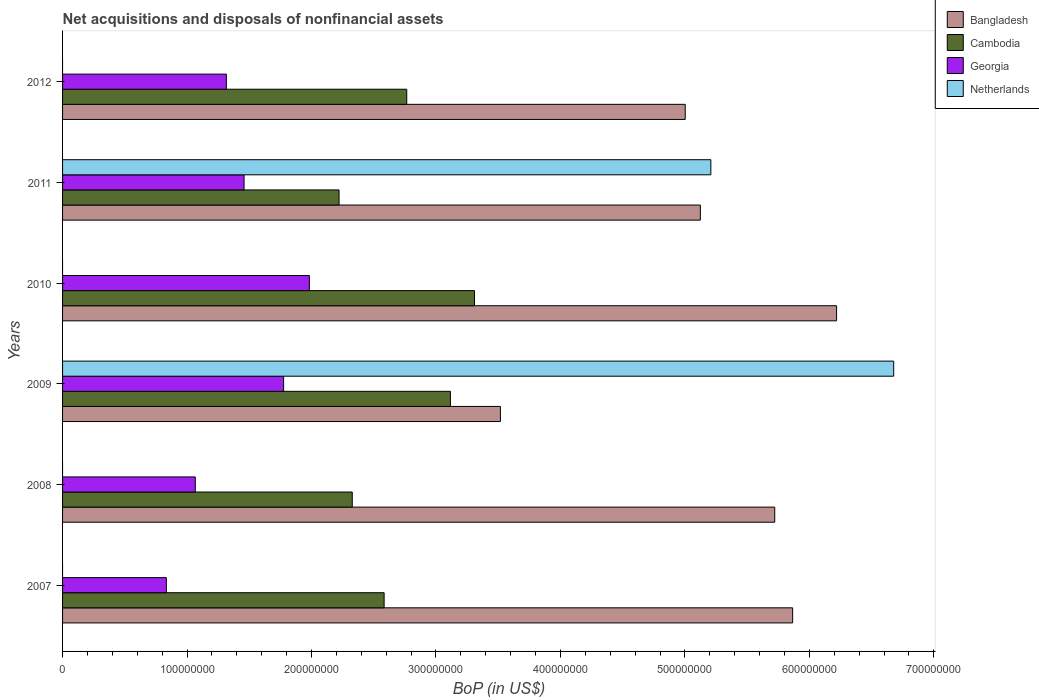Are the number of bars per tick equal to the number of legend labels?
Your response must be concise. No. What is the Balance of Payments in Cambodia in 2011?
Keep it short and to the point. 2.22e+08. Across all years, what is the maximum Balance of Payments in Netherlands?
Your answer should be compact. 6.68e+08. Across all years, what is the minimum Balance of Payments in Bangladesh?
Your answer should be compact. 3.52e+08. What is the total Balance of Payments in Cambodia in the graph?
Provide a short and direct response. 1.63e+09. What is the difference between the Balance of Payments in Bangladesh in 2007 and that in 2009?
Offer a very short reply. 2.35e+08. What is the difference between the Balance of Payments in Netherlands in 2009 and the Balance of Payments in Georgia in 2011?
Keep it short and to the point. 5.22e+08. What is the average Balance of Payments in Bangladesh per year?
Your response must be concise. 5.24e+08. In the year 2009, what is the difference between the Balance of Payments in Bangladesh and Balance of Payments in Georgia?
Provide a succinct answer. 1.74e+08. In how many years, is the Balance of Payments in Bangladesh greater than 60000000 US$?
Offer a very short reply. 6. What is the ratio of the Balance of Payments in Cambodia in 2008 to that in 2012?
Your answer should be compact. 0.84. Is the Balance of Payments in Bangladesh in 2008 less than that in 2011?
Make the answer very short. No. Is the difference between the Balance of Payments in Bangladesh in 2007 and 2009 greater than the difference between the Balance of Payments in Georgia in 2007 and 2009?
Keep it short and to the point. Yes. What is the difference between the highest and the second highest Balance of Payments in Bangladesh?
Offer a terse response. 3.53e+07. What is the difference between the highest and the lowest Balance of Payments in Cambodia?
Provide a short and direct response. 1.09e+08. Is it the case that in every year, the sum of the Balance of Payments in Georgia and Balance of Payments in Cambodia is greater than the sum of Balance of Payments in Bangladesh and Balance of Payments in Netherlands?
Provide a short and direct response. Yes. What is the difference between two consecutive major ticks on the X-axis?
Ensure brevity in your answer.  1.00e+08. Are the values on the major ticks of X-axis written in scientific E-notation?
Make the answer very short. No. Does the graph contain grids?
Offer a terse response. No. What is the title of the graph?
Give a very brief answer. Net acquisitions and disposals of nonfinancial assets. Does "Pakistan" appear as one of the legend labels in the graph?
Your answer should be compact. No. What is the label or title of the X-axis?
Provide a succinct answer. BoP (in US$). What is the label or title of the Y-axis?
Give a very brief answer. Years. What is the BoP (in US$) of Bangladesh in 2007?
Give a very brief answer. 5.87e+08. What is the BoP (in US$) in Cambodia in 2007?
Provide a short and direct response. 2.58e+08. What is the BoP (in US$) of Georgia in 2007?
Your answer should be very brief. 8.34e+07. What is the BoP (in US$) in Netherlands in 2007?
Your response must be concise. 0. What is the BoP (in US$) in Bangladesh in 2008?
Your answer should be very brief. 5.72e+08. What is the BoP (in US$) in Cambodia in 2008?
Offer a very short reply. 2.33e+08. What is the BoP (in US$) of Georgia in 2008?
Give a very brief answer. 1.07e+08. What is the BoP (in US$) of Netherlands in 2008?
Offer a terse response. 0. What is the BoP (in US$) in Bangladesh in 2009?
Your response must be concise. 3.52e+08. What is the BoP (in US$) in Cambodia in 2009?
Keep it short and to the point. 3.12e+08. What is the BoP (in US$) in Georgia in 2009?
Your response must be concise. 1.78e+08. What is the BoP (in US$) in Netherlands in 2009?
Provide a short and direct response. 6.68e+08. What is the BoP (in US$) of Bangladesh in 2010?
Your answer should be very brief. 6.22e+08. What is the BoP (in US$) of Cambodia in 2010?
Offer a very short reply. 3.31e+08. What is the BoP (in US$) of Georgia in 2010?
Your answer should be compact. 1.98e+08. What is the BoP (in US$) in Netherlands in 2010?
Your response must be concise. 0. What is the BoP (in US$) of Bangladesh in 2011?
Your answer should be compact. 5.12e+08. What is the BoP (in US$) in Cambodia in 2011?
Provide a succinct answer. 2.22e+08. What is the BoP (in US$) of Georgia in 2011?
Give a very brief answer. 1.46e+08. What is the BoP (in US$) of Netherlands in 2011?
Provide a succinct answer. 5.21e+08. What is the BoP (in US$) in Bangladesh in 2012?
Your response must be concise. 5.00e+08. What is the BoP (in US$) in Cambodia in 2012?
Make the answer very short. 2.77e+08. What is the BoP (in US$) in Georgia in 2012?
Ensure brevity in your answer.  1.32e+08. What is the BoP (in US$) of Netherlands in 2012?
Offer a terse response. 0. Across all years, what is the maximum BoP (in US$) of Bangladesh?
Your answer should be compact. 6.22e+08. Across all years, what is the maximum BoP (in US$) in Cambodia?
Give a very brief answer. 3.31e+08. Across all years, what is the maximum BoP (in US$) in Georgia?
Ensure brevity in your answer.  1.98e+08. Across all years, what is the maximum BoP (in US$) of Netherlands?
Offer a terse response. 6.68e+08. Across all years, what is the minimum BoP (in US$) in Bangladesh?
Provide a succinct answer. 3.52e+08. Across all years, what is the minimum BoP (in US$) in Cambodia?
Your response must be concise. 2.22e+08. Across all years, what is the minimum BoP (in US$) in Georgia?
Give a very brief answer. 8.34e+07. What is the total BoP (in US$) in Bangladesh in the graph?
Your answer should be very brief. 3.15e+09. What is the total BoP (in US$) in Cambodia in the graph?
Your answer should be compact. 1.63e+09. What is the total BoP (in US$) of Georgia in the graph?
Your answer should be compact. 8.43e+08. What is the total BoP (in US$) in Netherlands in the graph?
Make the answer very short. 1.19e+09. What is the difference between the BoP (in US$) in Bangladesh in 2007 and that in 2008?
Ensure brevity in your answer.  1.44e+07. What is the difference between the BoP (in US$) of Cambodia in 2007 and that in 2008?
Your answer should be compact. 2.56e+07. What is the difference between the BoP (in US$) in Georgia in 2007 and that in 2008?
Your answer should be compact. -2.32e+07. What is the difference between the BoP (in US$) in Bangladesh in 2007 and that in 2009?
Ensure brevity in your answer.  2.35e+08. What is the difference between the BoP (in US$) in Cambodia in 2007 and that in 2009?
Provide a short and direct response. -5.33e+07. What is the difference between the BoP (in US$) of Georgia in 2007 and that in 2009?
Make the answer very short. -9.42e+07. What is the difference between the BoP (in US$) in Bangladesh in 2007 and that in 2010?
Give a very brief answer. -3.53e+07. What is the difference between the BoP (in US$) of Cambodia in 2007 and that in 2010?
Offer a very short reply. -7.26e+07. What is the difference between the BoP (in US$) in Georgia in 2007 and that in 2010?
Provide a short and direct response. -1.15e+08. What is the difference between the BoP (in US$) of Bangladesh in 2007 and that in 2011?
Make the answer very short. 7.41e+07. What is the difference between the BoP (in US$) in Cambodia in 2007 and that in 2011?
Ensure brevity in your answer.  3.62e+07. What is the difference between the BoP (in US$) of Georgia in 2007 and that in 2011?
Ensure brevity in your answer.  -6.24e+07. What is the difference between the BoP (in US$) of Bangladesh in 2007 and that in 2012?
Provide a short and direct response. 8.63e+07. What is the difference between the BoP (in US$) in Cambodia in 2007 and that in 2012?
Ensure brevity in your answer.  -1.82e+07. What is the difference between the BoP (in US$) of Georgia in 2007 and that in 2012?
Make the answer very short. -4.82e+07. What is the difference between the BoP (in US$) of Bangladesh in 2008 and that in 2009?
Give a very brief answer. 2.20e+08. What is the difference between the BoP (in US$) of Cambodia in 2008 and that in 2009?
Provide a short and direct response. -7.89e+07. What is the difference between the BoP (in US$) in Georgia in 2008 and that in 2009?
Your response must be concise. -7.10e+07. What is the difference between the BoP (in US$) in Bangladesh in 2008 and that in 2010?
Your answer should be compact. -4.97e+07. What is the difference between the BoP (in US$) of Cambodia in 2008 and that in 2010?
Offer a terse response. -9.82e+07. What is the difference between the BoP (in US$) in Georgia in 2008 and that in 2010?
Ensure brevity in your answer.  -9.17e+07. What is the difference between the BoP (in US$) of Bangladesh in 2008 and that in 2011?
Your answer should be compact. 5.98e+07. What is the difference between the BoP (in US$) in Cambodia in 2008 and that in 2011?
Your answer should be very brief. 1.06e+07. What is the difference between the BoP (in US$) of Georgia in 2008 and that in 2011?
Provide a succinct answer. -3.92e+07. What is the difference between the BoP (in US$) in Bangladesh in 2008 and that in 2012?
Keep it short and to the point. 7.19e+07. What is the difference between the BoP (in US$) of Cambodia in 2008 and that in 2012?
Make the answer very short. -4.38e+07. What is the difference between the BoP (in US$) in Georgia in 2008 and that in 2012?
Your response must be concise. -2.50e+07. What is the difference between the BoP (in US$) of Bangladesh in 2009 and that in 2010?
Your response must be concise. -2.70e+08. What is the difference between the BoP (in US$) in Cambodia in 2009 and that in 2010?
Your answer should be very brief. -1.94e+07. What is the difference between the BoP (in US$) of Georgia in 2009 and that in 2010?
Your answer should be very brief. -2.07e+07. What is the difference between the BoP (in US$) in Bangladesh in 2009 and that in 2011?
Offer a terse response. -1.61e+08. What is the difference between the BoP (in US$) in Cambodia in 2009 and that in 2011?
Your response must be concise. 8.95e+07. What is the difference between the BoP (in US$) of Georgia in 2009 and that in 2011?
Ensure brevity in your answer.  3.18e+07. What is the difference between the BoP (in US$) in Netherlands in 2009 and that in 2011?
Give a very brief answer. 1.47e+08. What is the difference between the BoP (in US$) of Bangladesh in 2009 and that in 2012?
Your response must be concise. -1.48e+08. What is the difference between the BoP (in US$) of Cambodia in 2009 and that in 2012?
Your response must be concise. 3.51e+07. What is the difference between the BoP (in US$) in Georgia in 2009 and that in 2012?
Provide a succinct answer. 4.60e+07. What is the difference between the BoP (in US$) of Bangladesh in 2010 and that in 2011?
Your answer should be compact. 1.09e+08. What is the difference between the BoP (in US$) of Cambodia in 2010 and that in 2011?
Make the answer very short. 1.09e+08. What is the difference between the BoP (in US$) in Georgia in 2010 and that in 2011?
Ensure brevity in your answer.  5.25e+07. What is the difference between the BoP (in US$) of Bangladesh in 2010 and that in 2012?
Your response must be concise. 1.22e+08. What is the difference between the BoP (in US$) of Cambodia in 2010 and that in 2012?
Offer a terse response. 5.44e+07. What is the difference between the BoP (in US$) in Georgia in 2010 and that in 2012?
Ensure brevity in your answer.  6.67e+07. What is the difference between the BoP (in US$) of Bangladesh in 2011 and that in 2012?
Keep it short and to the point. 1.21e+07. What is the difference between the BoP (in US$) in Cambodia in 2011 and that in 2012?
Give a very brief answer. -5.44e+07. What is the difference between the BoP (in US$) in Georgia in 2011 and that in 2012?
Your answer should be compact. 1.42e+07. What is the difference between the BoP (in US$) in Bangladesh in 2007 and the BoP (in US$) in Cambodia in 2008?
Ensure brevity in your answer.  3.54e+08. What is the difference between the BoP (in US$) of Bangladesh in 2007 and the BoP (in US$) of Georgia in 2008?
Your answer should be compact. 4.80e+08. What is the difference between the BoP (in US$) of Cambodia in 2007 and the BoP (in US$) of Georgia in 2008?
Provide a short and direct response. 1.52e+08. What is the difference between the BoP (in US$) of Bangladesh in 2007 and the BoP (in US$) of Cambodia in 2009?
Make the answer very short. 2.75e+08. What is the difference between the BoP (in US$) of Bangladesh in 2007 and the BoP (in US$) of Georgia in 2009?
Ensure brevity in your answer.  4.09e+08. What is the difference between the BoP (in US$) in Bangladesh in 2007 and the BoP (in US$) in Netherlands in 2009?
Offer a very short reply. -8.12e+07. What is the difference between the BoP (in US$) of Cambodia in 2007 and the BoP (in US$) of Georgia in 2009?
Provide a succinct answer. 8.07e+07. What is the difference between the BoP (in US$) in Cambodia in 2007 and the BoP (in US$) in Netherlands in 2009?
Your answer should be compact. -4.09e+08. What is the difference between the BoP (in US$) of Georgia in 2007 and the BoP (in US$) of Netherlands in 2009?
Give a very brief answer. -5.84e+08. What is the difference between the BoP (in US$) of Bangladesh in 2007 and the BoP (in US$) of Cambodia in 2010?
Ensure brevity in your answer.  2.56e+08. What is the difference between the BoP (in US$) of Bangladesh in 2007 and the BoP (in US$) of Georgia in 2010?
Make the answer very short. 3.88e+08. What is the difference between the BoP (in US$) of Cambodia in 2007 and the BoP (in US$) of Georgia in 2010?
Provide a succinct answer. 6.01e+07. What is the difference between the BoP (in US$) of Bangladesh in 2007 and the BoP (in US$) of Cambodia in 2011?
Your answer should be very brief. 3.64e+08. What is the difference between the BoP (in US$) in Bangladesh in 2007 and the BoP (in US$) in Georgia in 2011?
Provide a short and direct response. 4.41e+08. What is the difference between the BoP (in US$) of Bangladesh in 2007 and the BoP (in US$) of Netherlands in 2011?
Provide a succinct answer. 6.57e+07. What is the difference between the BoP (in US$) of Cambodia in 2007 and the BoP (in US$) of Georgia in 2011?
Your answer should be very brief. 1.13e+08. What is the difference between the BoP (in US$) in Cambodia in 2007 and the BoP (in US$) in Netherlands in 2011?
Make the answer very short. -2.62e+08. What is the difference between the BoP (in US$) of Georgia in 2007 and the BoP (in US$) of Netherlands in 2011?
Keep it short and to the point. -4.37e+08. What is the difference between the BoP (in US$) of Bangladesh in 2007 and the BoP (in US$) of Cambodia in 2012?
Give a very brief answer. 3.10e+08. What is the difference between the BoP (in US$) in Bangladesh in 2007 and the BoP (in US$) in Georgia in 2012?
Give a very brief answer. 4.55e+08. What is the difference between the BoP (in US$) in Cambodia in 2007 and the BoP (in US$) in Georgia in 2012?
Ensure brevity in your answer.  1.27e+08. What is the difference between the BoP (in US$) in Bangladesh in 2008 and the BoP (in US$) in Cambodia in 2009?
Your answer should be very brief. 2.61e+08. What is the difference between the BoP (in US$) of Bangladesh in 2008 and the BoP (in US$) of Georgia in 2009?
Your answer should be compact. 3.95e+08. What is the difference between the BoP (in US$) of Bangladesh in 2008 and the BoP (in US$) of Netherlands in 2009?
Your answer should be compact. -9.56e+07. What is the difference between the BoP (in US$) of Cambodia in 2008 and the BoP (in US$) of Georgia in 2009?
Offer a very short reply. 5.51e+07. What is the difference between the BoP (in US$) in Cambodia in 2008 and the BoP (in US$) in Netherlands in 2009?
Your answer should be compact. -4.35e+08. What is the difference between the BoP (in US$) in Georgia in 2008 and the BoP (in US$) in Netherlands in 2009?
Offer a very short reply. -5.61e+08. What is the difference between the BoP (in US$) in Bangladesh in 2008 and the BoP (in US$) in Cambodia in 2010?
Offer a terse response. 2.41e+08. What is the difference between the BoP (in US$) of Bangladesh in 2008 and the BoP (in US$) of Georgia in 2010?
Offer a terse response. 3.74e+08. What is the difference between the BoP (in US$) in Cambodia in 2008 and the BoP (in US$) in Georgia in 2010?
Your answer should be very brief. 3.45e+07. What is the difference between the BoP (in US$) in Bangladesh in 2008 and the BoP (in US$) in Cambodia in 2011?
Your answer should be compact. 3.50e+08. What is the difference between the BoP (in US$) of Bangladesh in 2008 and the BoP (in US$) of Georgia in 2011?
Offer a terse response. 4.26e+08. What is the difference between the BoP (in US$) in Bangladesh in 2008 and the BoP (in US$) in Netherlands in 2011?
Ensure brevity in your answer.  5.13e+07. What is the difference between the BoP (in US$) in Cambodia in 2008 and the BoP (in US$) in Georgia in 2011?
Provide a succinct answer. 8.69e+07. What is the difference between the BoP (in US$) of Cambodia in 2008 and the BoP (in US$) of Netherlands in 2011?
Make the answer very short. -2.88e+08. What is the difference between the BoP (in US$) of Georgia in 2008 and the BoP (in US$) of Netherlands in 2011?
Keep it short and to the point. -4.14e+08. What is the difference between the BoP (in US$) in Bangladesh in 2008 and the BoP (in US$) in Cambodia in 2012?
Offer a very short reply. 2.96e+08. What is the difference between the BoP (in US$) in Bangladesh in 2008 and the BoP (in US$) in Georgia in 2012?
Keep it short and to the point. 4.41e+08. What is the difference between the BoP (in US$) in Cambodia in 2008 and the BoP (in US$) in Georgia in 2012?
Offer a terse response. 1.01e+08. What is the difference between the BoP (in US$) in Bangladesh in 2009 and the BoP (in US$) in Cambodia in 2010?
Make the answer very short. 2.08e+07. What is the difference between the BoP (in US$) in Bangladesh in 2009 and the BoP (in US$) in Georgia in 2010?
Offer a very short reply. 1.53e+08. What is the difference between the BoP (in US$) of Cambodia in 2009 and the BoP (in US$) of Georgia in 2010?
Provide a short and direct response. 1.13e+08. What is the difference between the BoP (in US$) of Bangladesh in 2009 and the BoP (in US$) of Cambodia in 2011?
Keep it short and to the point. 1.30e+08. What is the difference between the BoP (in US$) in Bangladesh in 2009 and the BoP (in US$) in Georgia in 2011?
Keep it short and to the point. 2.06e+08. What is the difference between the BoP (in US$) in Bangladesh in 2009 and the BoP (in US$) in Netherlands in 2011?
Your response must be concise. -1.69e+08. What is the difference between the BoP (in US$) of Cambodia in 2009 and the BoP (in US$) of Georgia in 2011?
Your answer should be compact. 1.66e+08. What is the difference between the BoP (in US$) of Cambodia in 2009 and the BoP (in US$) of Netherlands in 2011?
Offer a terse response. -2.09e+08. What is the difference between the BoP (in US$) in Georgia in 2009 and the BoP (in US$) in Netherlands in 2011?
Offer a terse response. -3.43e+08. What is the difference between the BoP (in US$) of Bangladesh in 2009 and the BoP (in US$) of Cambodia in 2012?
Make the answer very short. 7.52e+07. What is the difference between the BoP (in US$) in Bangladesh in 2009 and the BoP (in US$) in Georgia in 2012?
Keep it short and to the point. 2.20e+08. What is the difference between the BoP (in US$) in Cambodia in 2009 and the BoP (in US$) in Georgia in 2012?
Your response must be concise. 1.80e+08. What is the difference between the BoP (in US$) in Bangladesh in 2010 and the BoP (in US$) in Cambodia in 2011?
Keep it short and to the point. 4.00e+08. What is the difference between the BoP (in US$) in Bangladesh in 2010 and the BoP (in US$) in Georgia in 2011?
Your response must be concise. 4.76e+08. What is the difference between the BoP (in US$) in Bangladesh in 2010 and the BoP (in US$) in Netherlands in 2011?
Offer a very short reply. 1.01e+08. What is the difference between the BoP (in US$) of Cambodia in 2010 and the BoP (in US$) of Georgia in 2011?
Your answer should be very brief. 1.85e+08. What is the difference between the BoP (in US$) in Cambodia in 2010 and the BoP (in US$) in Netherlands in 2011?
Make the answer very short. -1.90e+08. What is the difference between the BoP (in US$) in Georgia in 2010 and the BoP (in US$) in Netherlands in 2011?
Provide a succinct answer. -3.23e+08. What is the difference between the BoP (in US$) of Bangladesh in 2010 and the BoP (in US$) of Cambodia in 2012?
Your answer should be very brief. 3.45e+08. What is the difference between the BoP (in US$) in Bangladesh in 2010 and the BoP (in US$) in Georgia in 2012?
Keep it short and to the point. 4.90e+08. What is the difference between the BoP (in US$) in Cambodia in 2010 and the BoP (in US$) in Georgia in 2012?
Your answer should be very brief. 1.99e+08. What is the difference between the BoP (in US$) of Bangladesh in 2011 and the BoP (in US$) of Cambodia in 2012?
Provide a succinct answer. 2.36e+08. What is the difference between the BoP (in US$) of Bangladesh in 2011 and the BoP (in US$) of Georgia in 2012?
Offer a very short reply. 3.81e+08. What is the difference between the BoP (in US$) in Cambodia in 2011 and the BoP (in US$) in Georgia in 2012?
Give a very brief answer. 9.05e+07. What is the average BoP (in US$) in Bangladesh per year?
Provide a succinct answer. 5.24e+08. What is the average BoP (in US$) of Cambodia per year?
Provide a succinct answer. 2.72e+08. What is the average BoP (in US$) of Georgia per year?
Offer a very short reply. 1.41e+08. What is the average BoP (in US$) in Netherlands per year?
Your answer should be very brief. 1.98e+08. In the year 2007, what is the difference between the BoP (in US$) in Bangladesh and BoP (in US$) in Cambodia?
Provide a succinct answer. 3.28e+08. In the year 2007, what is the difference between the BoP (in US$) of Bangladesh and BoP (in US$) of Georgia?
Ensure brevity in your answer.  5.03e+08. In the year 2007, what is the difference between the BoP (in US$) of Cambodia and BoP (in US$) of Georgia?
Provide a succinct answer. 1.75e+08. In the year 2008, what is the difference between the BoP (in US$) of Bangladesh and BoP (in US$) of Cambodia?
Offer a very short reply. 3.39e+08. In the year 2008, what is the difference between the BoP (in US$) in Bangladesh and BoP (in US$) in Georgia?
Offer a very short reply. 4.66e+08. In the year 2008, what is the difference between the BoP (in US$) in Cambodia and BoP (in US$) in Georgia?
Offer a very short reply. 1.26e+08. In the year 2009, what is the difference between the BoP (in US$) in Bangladesh and BoP (in US$) in Cambodia?
Offer a terse response. 4.02e+07. In the year 2009, what is the difference between the BoP (in US$) of Bangladesh and BoP (in US$) of Georgia?
Provide a short and direct response. 1.74e+08. In the year 2009, what is the difference between the BoP (in US$) in Bangladesh and BoP (in US$) in Netherlands?
Offer a very short reply. -3.16e+08. In the year 2009, what is the difference between the BoP (in US$) in Cambodia and BoP (in US$) in Georgia?
Offer a terse response. 1.34e+08. In the year 2009, what is the difference between the BoP (in US$) of Cambodia and BoP (in US$) of Netherlands?
Your answer should be very brief. -3.56e+08. In the year 2009, what is the difference between the BoP (in US$) in Georgia and BoP (in US$) in Netherlands?
Make the answer very short. -4.90e+08. In the year 2010, what is the difference between the BoP (in US$) in Bangladesh and BoP (in US$) in Cambodia?
Your response must be concise. 2.91e+08. In the year 2010, what is the difference between the BoP (in US$) in Bangladesh and BoP (in US$) in Georgia?
Your response must be concise. 4.24e+08. In the year 2010, what is the difference between the BoP (in US$) in Cambodia and BoP (in US$) in Georgia?
Offer a very short reply. 1.33e+08. In the year 2011, what is the difference between the BoP (in US$) in Bangladesh and BoP (in US$) in Cambodia?
Provide a succinct answer. 2.90e+08. In the year 2011, what is the difference between the BoP (in US$) in Bangladesh and BoP (in US$) in Georgia?
Provide a short and direct response. 3.67e+08. In the year 2011, what is the difference between the BoP (in US$) of Bangladesh and BoP (in US$) of Netherlands?
Your response must be concise. -8.43e+06. In the year 2011, what is the difference between the BoP (in US$) of Cambodia and BoP (in US$) of Georgia?
Your answer should be compact. 7.63e+07. In the year 2011, what is the difference between the BoP (in US$) in Cambodia and BoP (in US$) in Netherlands?
Make the answer very short. -2.99e+08. In the year 2011, what is the difference between the BoP (in US$) of Georgia and BoP (in US$) of Netherlands?
Make the answer very short. -3.75e+08. In the year 2012, what is the difference between the BoP (in US$) of Bangladesh and BoP (in US$) of Cambodia?
Ensure brevity in your answer.  2.24e+08. In the year 2012, what is the difference between the BoP (in US$) in Bangladesh and BoP (in US$) in Georgia?
Offer a terse response. 3.69e+08. In the year 2012, what is the difference between the BoP (in US$) in Cambodia and BoP (in US$) in Georgia?
Provide a short and direct response. 1.45e+08. What is the ratio of the BoP (in US$) in Bangladesh in 2007 to that in 2008?
Keep it short and to the point. 1.03. What is the ratio of the BoP (in US$) of Cambodia in 2007 to that in 2008?
Offer a terse response. 1.11. What is the ratio of the BoP (in US$) of Georgia in 2007 to that in 2008?
Your answer should be very brief. 0.78. What is the ratio of the BoP (in US$) of Bangladesh in 2007 to that in 2009?
Keep it short and to the point. 1.67. What is the ratio of the BoP (in US$) of Cambodia in 2007 to that in 2009?
Offer a very short reply. 0.83. What is the ratio of the BoP (in US$) in Georgia in 2007 to that in 2009?
Ensure brevity in your answer.  0.47. What is the ratio of the BoP (in US$) in Bangladesh in 2007 to that in 2010?
Offer a very short reply. 0.94. What is the ratio of the BoP (in US$) in Cambodia in 2007 to that in 2010?
Give a very brief answer. 0.78. What is the ratio of the BoP (in US$) of Georgia in 2007 to that in 2010?
Make the answer very short. 0.42. What is the ratio of the BoP (in US$) in Bangladesh in 2007 to that in 2011?
Offer a very short reply. 1.14. What is the ratio of the BoP (in US$) of Cambodia in 2007 to that in 2011?
Offer a very short reply. 1.16. What is the ratio of the BoP (in US$) in Georgia in 2007 to that in 2011?
Keep it short and to the point. 0.57. What is the ratio of the BoP (in US$) of Bangladesh in 2007 to that in 2012?
Give a very brief answer. 1.17. What is the ratio of the BoP (in US$) of Cambodia in 2007 to that in 2012?
Your answer should be compact. 0.93. What is the ratio of the BoP (in US$) in Georgia in 2007 to that in 2012?
Your answer should be compact. 0.63. What is the ratio of the BoP (in US$) in Bangladesh in 2008 to that in 2009?
Offer a very short reply. 1.63. What is the ratio of the BoP (in US$) of Cambodia in 2008 to that in 2009?
Provide a succinct answer. 0.75. What is the ratio of the BoP (in US$) in Georgia in 2008 to that in 2009?
Keep it short and to the point. 0.6. What is the ratio of the BoP (in US$) of Bangladesh in 2008 to that in 2010?
Ensure brevity in your answer.  0.92. What is the ratio of the BoP (in US$) in Cambodia in 2008 to that in 2010?
Offer a terse response. 0.7. What is the ratio of the BoP (in US$) in Georgia in 2008 to that in 2010?
Give a very brief answer. 0.54. What is the ratio of the BoP (in US$) in Bangladesh in 2008 to that in 2011?
Your answer should be very brief. 1.12. What is the ratio of the BoP (in US$) in Cambodia in 2008 to that in 2011?
Keep it short and to the point. 1.05. What is the ratio of the BoP (in US$) in Georgia in 2008 to that in 2011?
Make the answer very short. 0.73. What is the ratio of the BoP (in US$) in Bangladesh in 2008 to that in 2012?
Your answer should be compact. 1.14. What is the ratio of the BoP (in US$) in Cambodia in 2008 to that in 2012?
Give a very brief answer. 0.84. What is the ratio of the BoP (in US$) in Georgia in 2008 to that in 2012?
Provide a succinct answer. 0.81. What is the ratio of the BoP (in US$) of Bangladesh in 2009 to that in 2010?
Provide a succinct answer. 0.57. What is the ratio of the BoP (in US$) in Cambodia in 2009 to that in 2010?
Provide a succinct answer. 0.94. What is the ratio of the BoP (in US$) in Georgia in 2009 to that in 2010?
Give a very brief answer. 0.9. What is the ratio of the BoP (in US$) in Bangladesh in 2009 to that in 2011?
Provide a short and direct response. 0.69. What is the ratio of the BoP (in US$) in Cambodia in 2009 to that in 2011?
Provide a succinct answer. 1.4. What is the ratio of the BoP (in US$) in Georgia in 2009 to that in 2011?
Provide a short and direct response. 1.22. What is the ratio of the BoP (in US$) of Netherlands in 2009 to that in 2011?
Provide a short and direct response. 1.28. What is the ratio of the BoP (in US$) of Bangladesh in 2009 to that in 2012?
Provide a succinct answer. 0.7. What is the ratio of the BoP (in US$) of Cambodia in 2009 to that in 2012?
Provide a short and direct response. 1.13. What is the ratio of the BoP (in US$) of Georgia in 2009 to that in 2012?
Your response must be concise. 1.35. What is the ratio of the BoP (in US$) in Bangladesh in 2010 to that in 2011?
Provide a succinct answer. 1.21. What is the ratio of the BoP (in US$) in Cambodia in 2010 to that in 2011?
Offer a very short reply. 1.49. What is the ratio of the BoP (in US$) in Georgia in 2010 to that in 2011?
Provide a short and direct response. 1.36. What is the ratio of the BoP (in US$) in Bangladesh in 2010 to that in 2012?
Provide a succinct answer. 1.24. What is the ratio of the BoP (in US$) in Cambodia in 2010 to that in 2012?
Ensure brevity in your answer.  1.2. What is the ratio of the BoP (in US$) of Georgia in 2010 to that in 2012?
Keep it short and to the point. 1.51. What is the ratio of the BoP (in US$) in Bangladesh in 2011 to that in 2012?
Offer a very short reply. 1.02. What is the ratio of the BoP (in US$) of Cambodia in 2011 to that in 2012?
Offer a terse response. 0.8. What is the ratio of the BoP (in US$) of Georgia in 2011 to that in 2012?
Provide a short and direct response. 1.11. What is the difference between the highest and the second highest BoP (in US$) of Bangladesh?
Offer a terse response. 3.53e+07. What is the difference between the highest and the second highest BoP (in US$) in Cambodia?
Your answer should be compact. 1.94e+07. What is the difference between the highest and the second highest BoP (in US$) in Georgia?
Provide a short and direct response. 2.07e+07. What is the difference between the highest and the lowest BoP (in US$) of Bangladesh?
Provide a succinct answer. 2.70e+08. What is the difference between the highest and the lowest BoP (in US$) of Cambodia?
Offer a terse response. 1.09e+08. What is the difference between the highest and the lowest BoP (in US$) of Georgia?
Keep it short and to the point. 1.15e+08. What is the difference between the highest and the lowest BoP (in US$) of Netherlands?
Provide a short and direct response. 6.68e+08. 